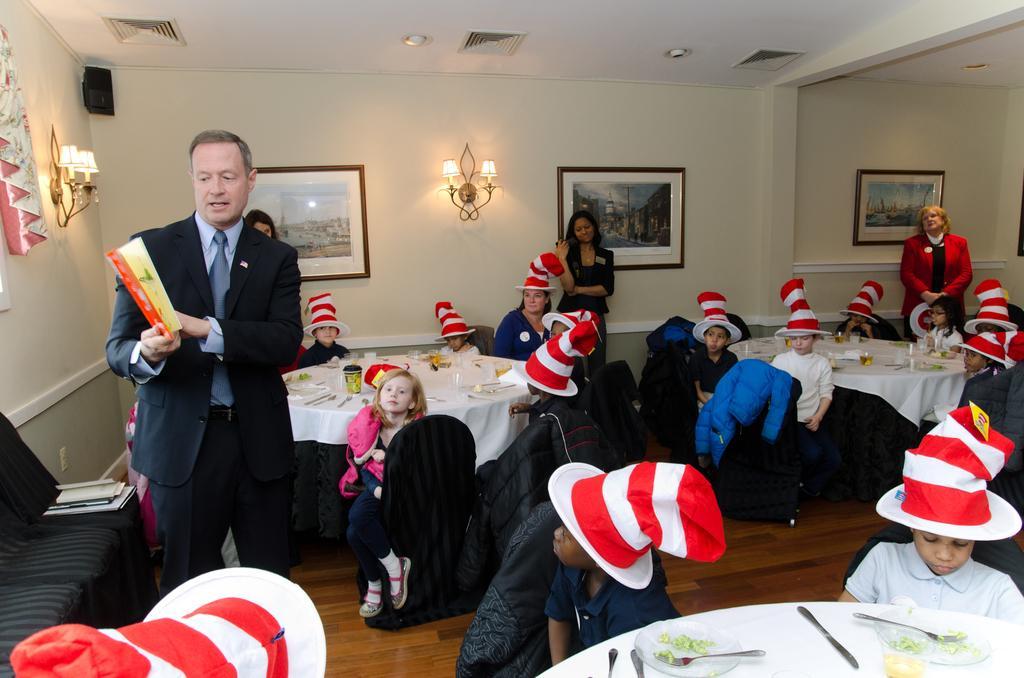Could you give a brief overview of what you see in this image? Here we can see few children are sitting on the chairs and there are four persons standing on the floor. He is holding a book with his hands. This is floor and there are chairs. In the background we can see a curtain, lights, frames, and a wall. 